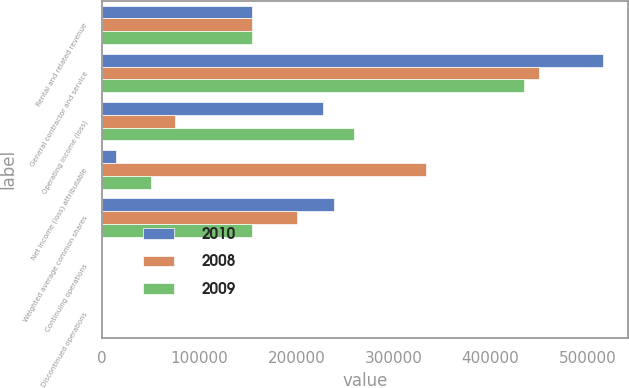Convert chart. <chart><loc_0><loc_0><loc_500><loc_500><stacked_bar_chart><ecel><fcel>Rental and related revenue<fcel>General contractor and service<fcel>Operating income (loss)<fcel>Net income (loss) attributable<fcel>Weighted average common shares<fcel>Continuing operations<fcel>Discontinued operations<nl><fcel>2010<fcel>154553<fcel>515361<fcel>227728<fcel>14108<fcel>238920<fcel>0.22<fcel>0.15<nl><fcel>2008<fcel>154553<fcel>449509<fcel>75210<fcel>333601<fcel>201206<fcel>1.58<fcel>0.09<nl><fcel>2009<fcel>154553<fcel>434624<fcel>259758<fcel>50408<fcel>154553<fcel>0.17<fcel>0.16<nl></chart> 